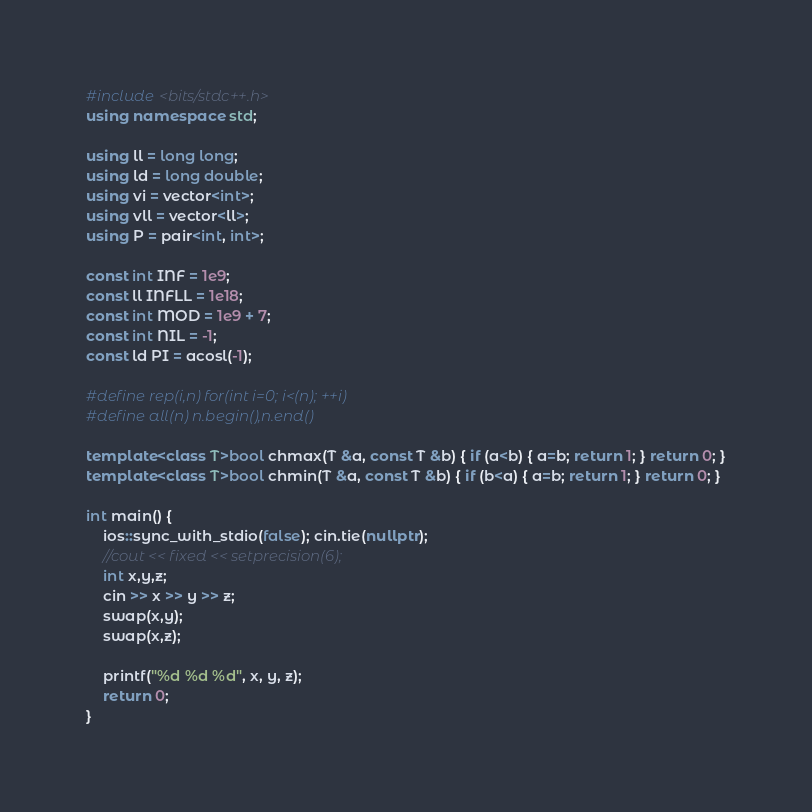<code> <loc_0><loc_0><loc_500><loc_500><_C++_>#include <bits/stdc++.h>
using namespace std;

using ll = long long;
using ld = long double;
using vi = vector<int>;
using vll = vector<ll>;
using P = pair<int, int>;

const int INF = 1e9;
const ll INFLL = 1e18;
const int MOD = 1e9 + 7;
const int NIL = -1;
const ld PI = acosl(-1);

#define rep(i,n) for(int i=0; i<(n); ++i)
#define all(n) n.begin(),n.end()

template<class T>bool chmax(T &a, const T &b) { if (a<b) { a=b; return 1; } return 0; }
template<class T>bool chmin(T &a, const T &b) { if (b<a) { a=b; return 1; } return 0; }

int main() {
	ios::sync_with_stdio(false); cin.tie(nullptr);
	//cout << fixed << setprecision(6);
	int x,y,z;
	cin >> x >> y >> z;
	swap(x,y);
	swap(x,z);

	printf("%d %d %d", x, y, z);
	return 0;
}</code> 